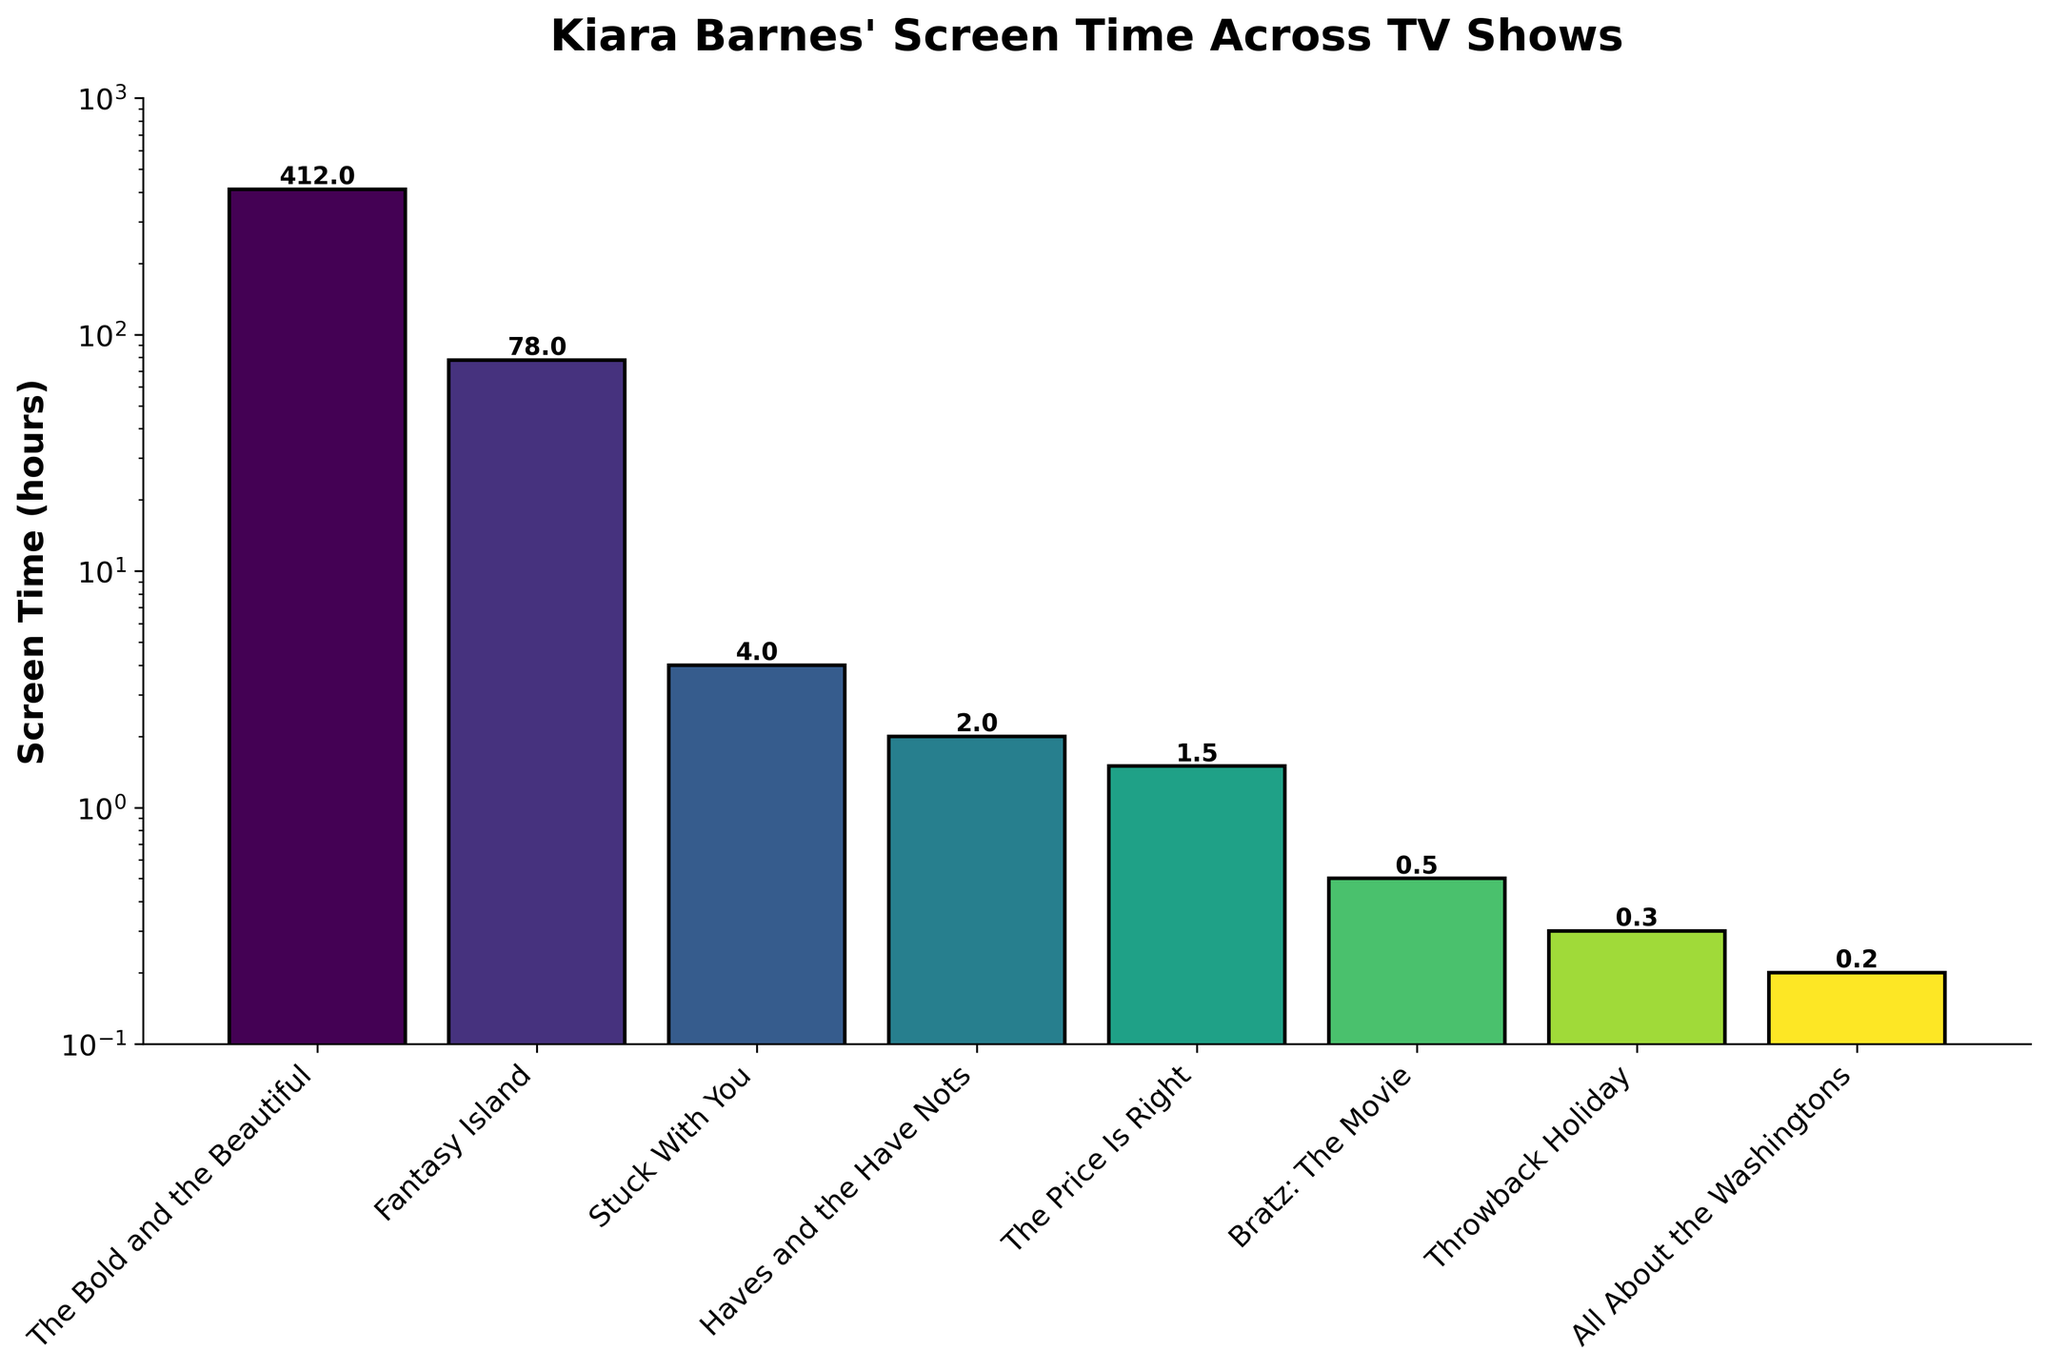What's the total screen time for all shows? To calculate the total screen time, sum the screen time values for all shows: 412 hours (The Bold and the Beautiful) + 78 hours (Fantasy Island) + 4 hours (Stuck With You) + 2 hours (Haves and the Have Nots) + 1.5 hours (The Price Is Right) + 0.5 hours (Bratz: The Movie) + 0.3 hours (Throwback Holiday) + 0.2 hours (All About the Washingtons).
Answer: 498.5 hours Which show has the greatest screen time? The highest bar in the bar chart indicates the show with the greatest screen time. The tallest bar corresponds to "The Bold and the Beautiful."
Answer: The Bold and the Beautiful Which show has the smallest screen time? The shortest bar in the bar chart indicates the show with the smallest screen time. The shortest bar corresponds to "All About the Washingtons."
Answer: All About the Washingtons How does the screen time for "Fantasy Island" compare to "The Price Is Right"? By visually comparing the height of the bars, "Fantasy Island" has a higher bar than "The Price Is Right." Specifically, compare 78 hours for "Fantasy Island" with 1.5 hours for "The Price Is Right."
Answer: Fantasy Island has more screen time What is the ratio of screen time between "The Bold and the Beautiful" and "Fantasy Island"? The screen time for "The Bold and the Beautiful" is 412 hours, and for "Fantasy Island" it is 78 hours. The ratio is 412/78.
Answer: About 5.3 What is the average screen time for "Stuck With You," "Haves and the Have Nots," and "The Price Is Right"? To find the average screen time, add the screen times for "Stuck With You" (4 hours), "Haves and the Have Nots" (2 hours), and "The Price Is Right" (1.5 hours). Sum = 4 + 2 + 1.5 = 7.5 hours. Then divide by the number of shows: 7.5 hours / 3 shows.
Answer: 2.5 hours Which shows have screen time less than 1 hour? By examining the bars with values less than 1 hour: "Bratz: The Movie" (0.5 hours), "Throwback Holiday" (0.3 hours), and "All About the Washingtons" (0.2 hours).
Answer: Bratz: The Movie, Throwback Holiday, All About the Washingtons How many shows have a screen time greater than 10 hours but less than 100 hours? Identifying the bars in the range 10-100 hours, only "Fantasy Island" falls in this range with 78 hours.
Answer: One show (Fantasy Island) What is the combined screen time of "Throwback Holiday" and "All About the Washingtons"? Add the screen time of "Throwback Holiday" (0.3 hours) and "All About the Washingtons" (0.2 hours). 0.3 + 0.2 = 0.5 hours.
Answer: 0.5 hours 